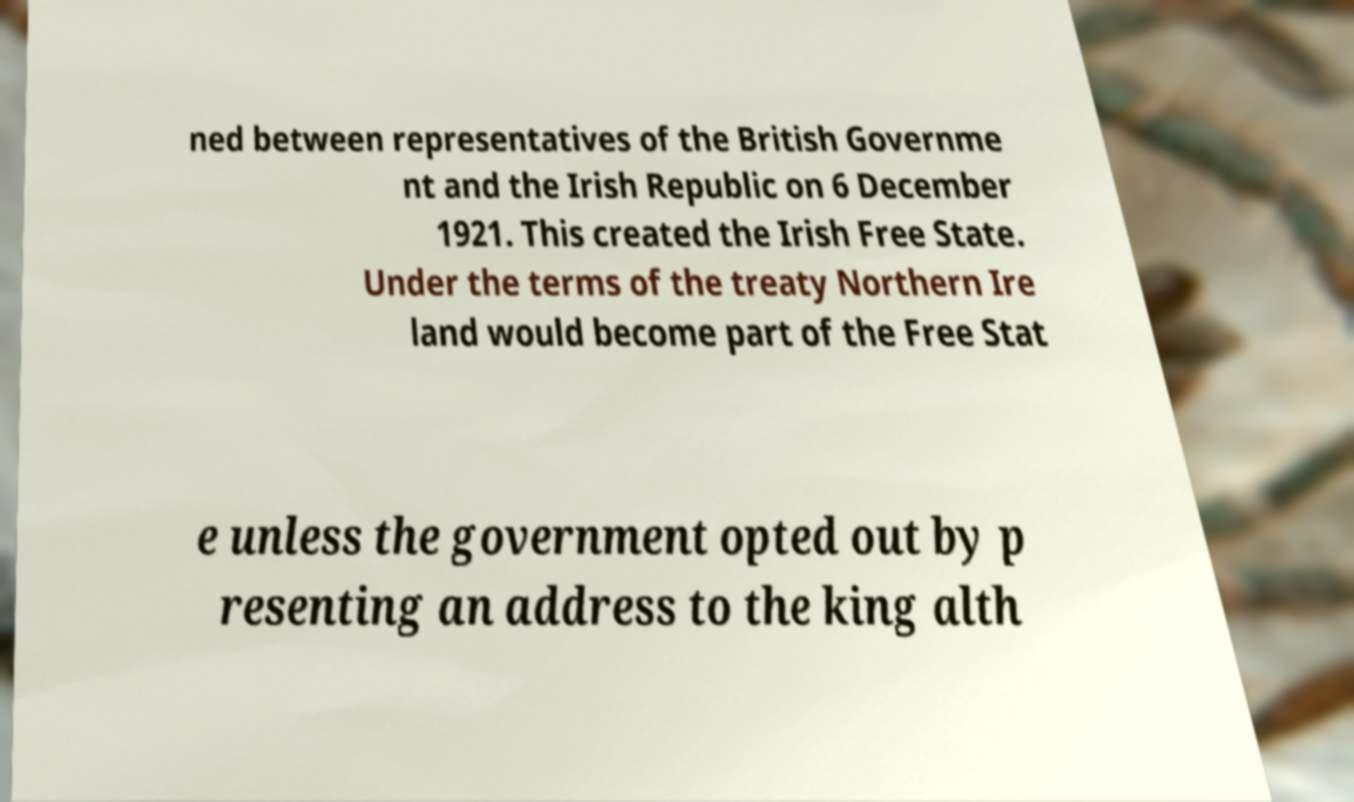For documentation purposes, I need the text within this image transcribed. Could you provide that? ned between representatives of the British Governme nt and the Irish Republic on 6 December 1921. This created the Irish Free State. Under the terms of the treaty Northern Ire land would become part of the Free Stat e unless the government opted out by p resenting an address to the king alth 